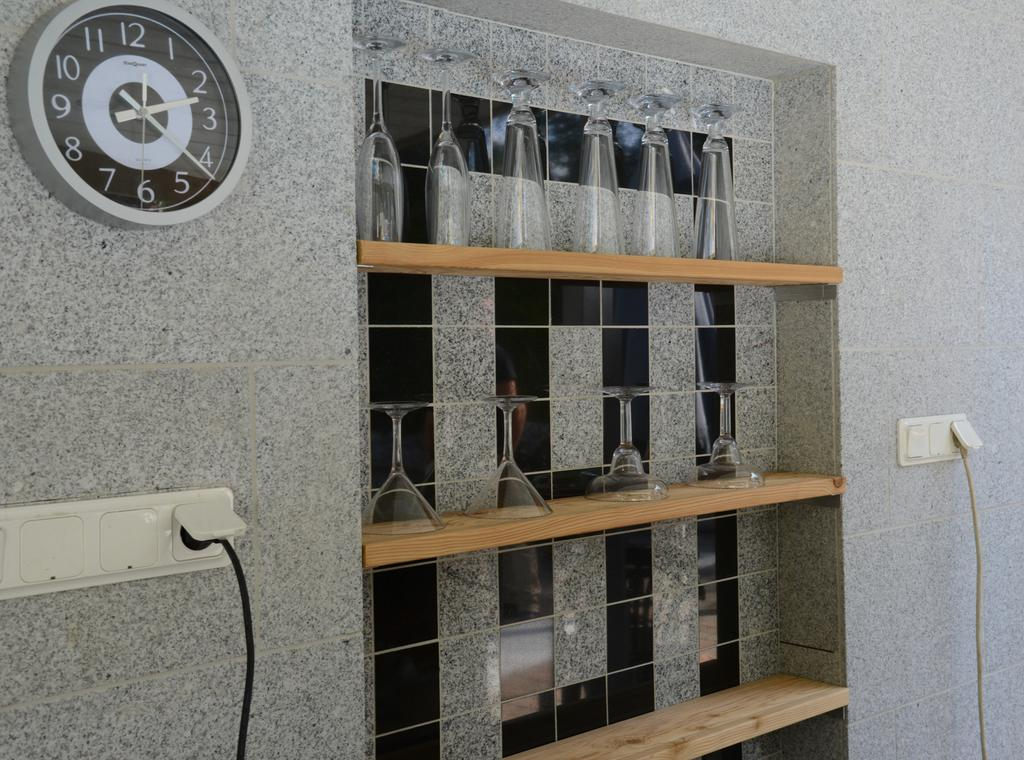<image>
Create a compact narrative representing the image presented. A clock on the wall by a shelf of glasses and the clock says MapQuest on it 